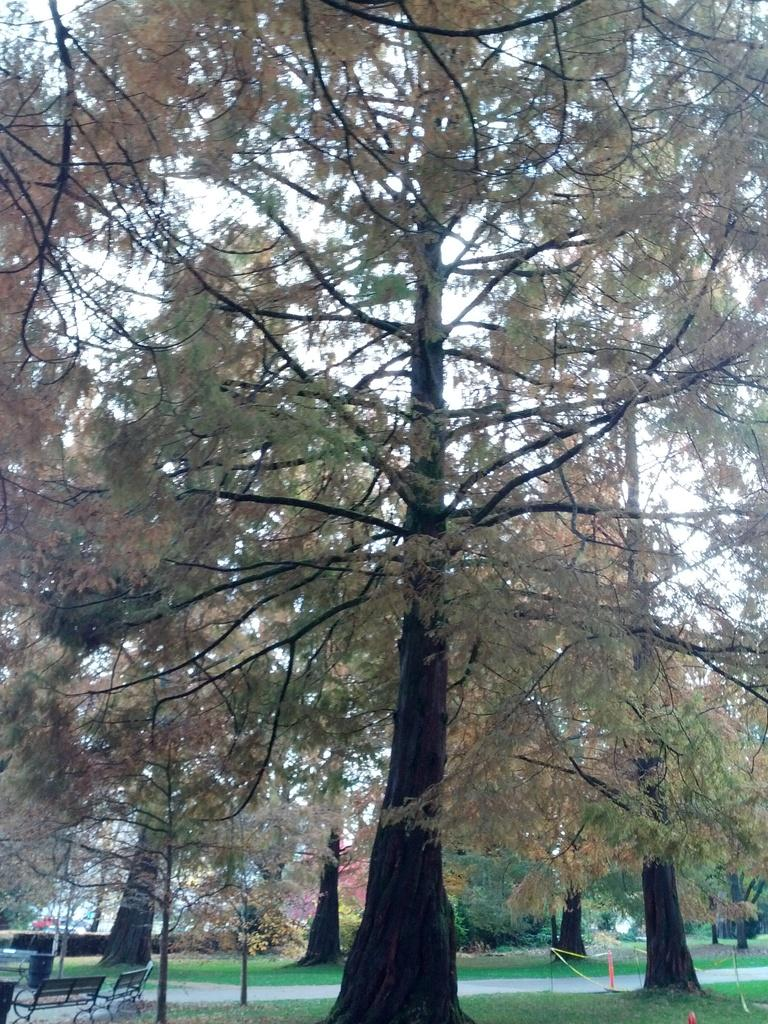What type of vegetation can be seen in the image? There are trees in the image. What type of seating is available in the image? There are benches in the image. What type of ground surface is present in the image? Grass is present in the image. What type of route is visible in the image? There is a path in the image. What is the color of the sky in the image? The sky is white in the image. Where is the throne located in the image? There is no throne present in the image. What type of writing instrument is used by the person sitting on the bench? There is no person or writing instrument visible in the image. 